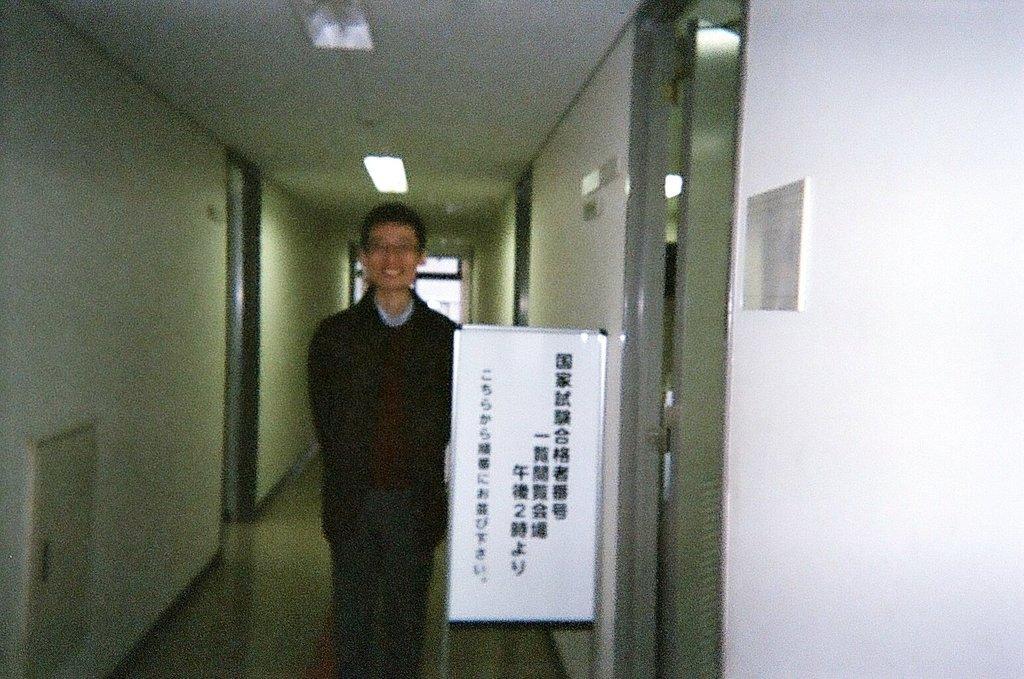In one or two sentences, can you explain what this image depicts? In this image I can see a person wearing black colored dress is standing and I can see a white colored board beside him. I can see the white colored walls, few doors, the ceiling and few lights to the ceiling. 